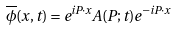Convert formula to latex. <formula><loc_0><loc_0><loc_500><loc_500>\overline { \phi } ( x , t ) = e ^ { i P \cdot x } A ( P ; t ) e ^ { - i P \cdot x }</formula> 